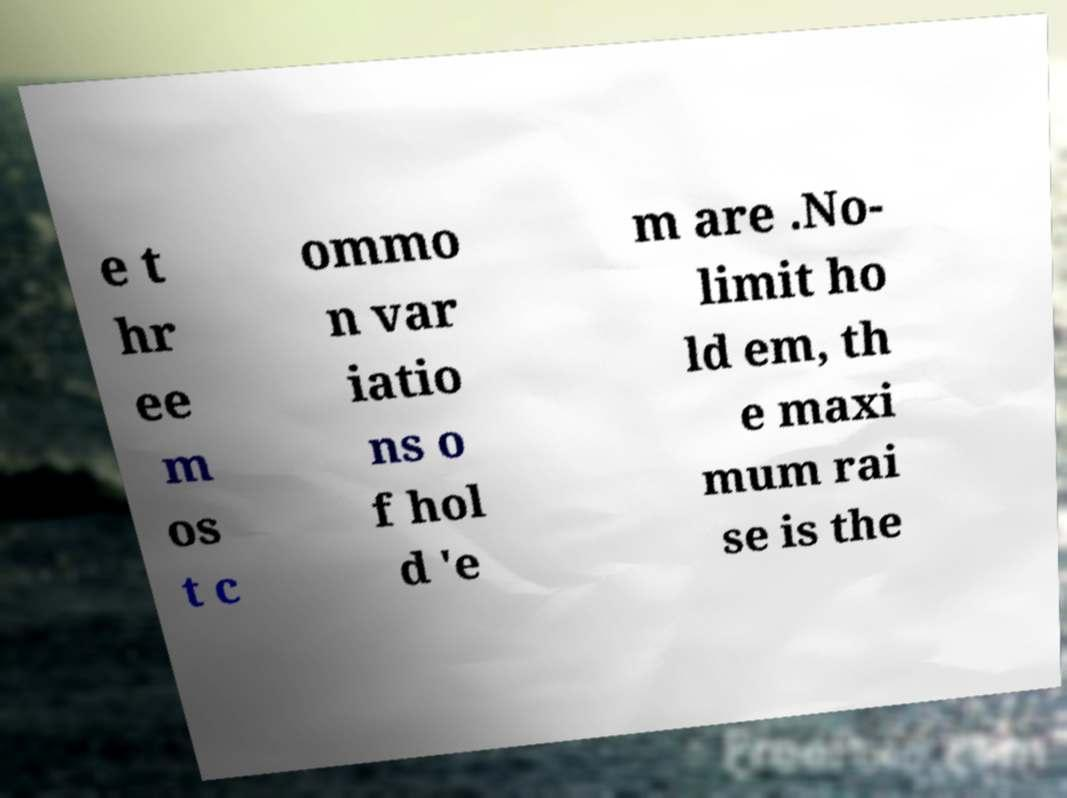I need the written content from this picture converted into text. Can you do that? e t hr ee m os t c ommo n var iatio ns o f hol d 'e m are .No- limit ho ld em, th e maxi mum rai se is the 